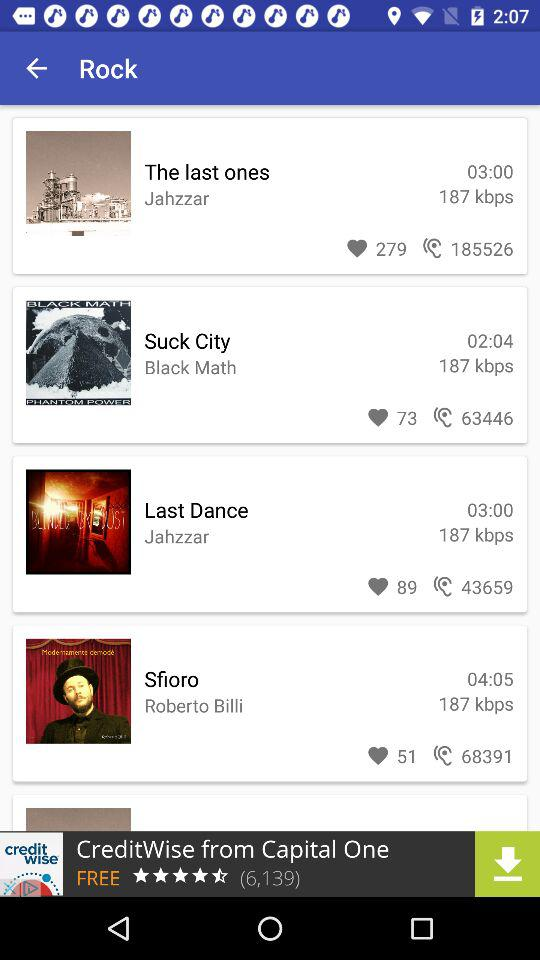What is the duration of "Suck City"? The duration is 2 minutes and 4 seconds. 